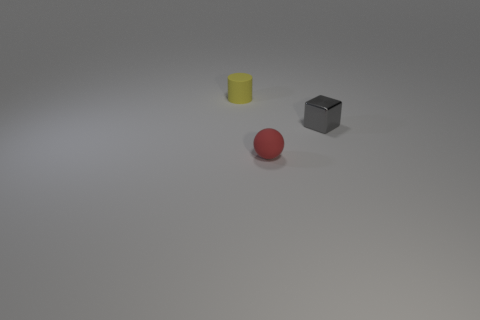Can you describe the lighting in this scene? The lighting in the scene is soft and appears to be coming from the top left, casting gentle shadows to the right of the objects. There's an overall diffuse light which doesn't create harsh highlights on the objects, contributing to a calm and more neutral atmosphere in the image. Does the lighting suggest anything about the time of day or location? Given the controlled nature of the shadows and the evenness of the lighting, this scene is likely set indoors under artificial lighting. It does not provide enough context to suggest a specific time of day. 